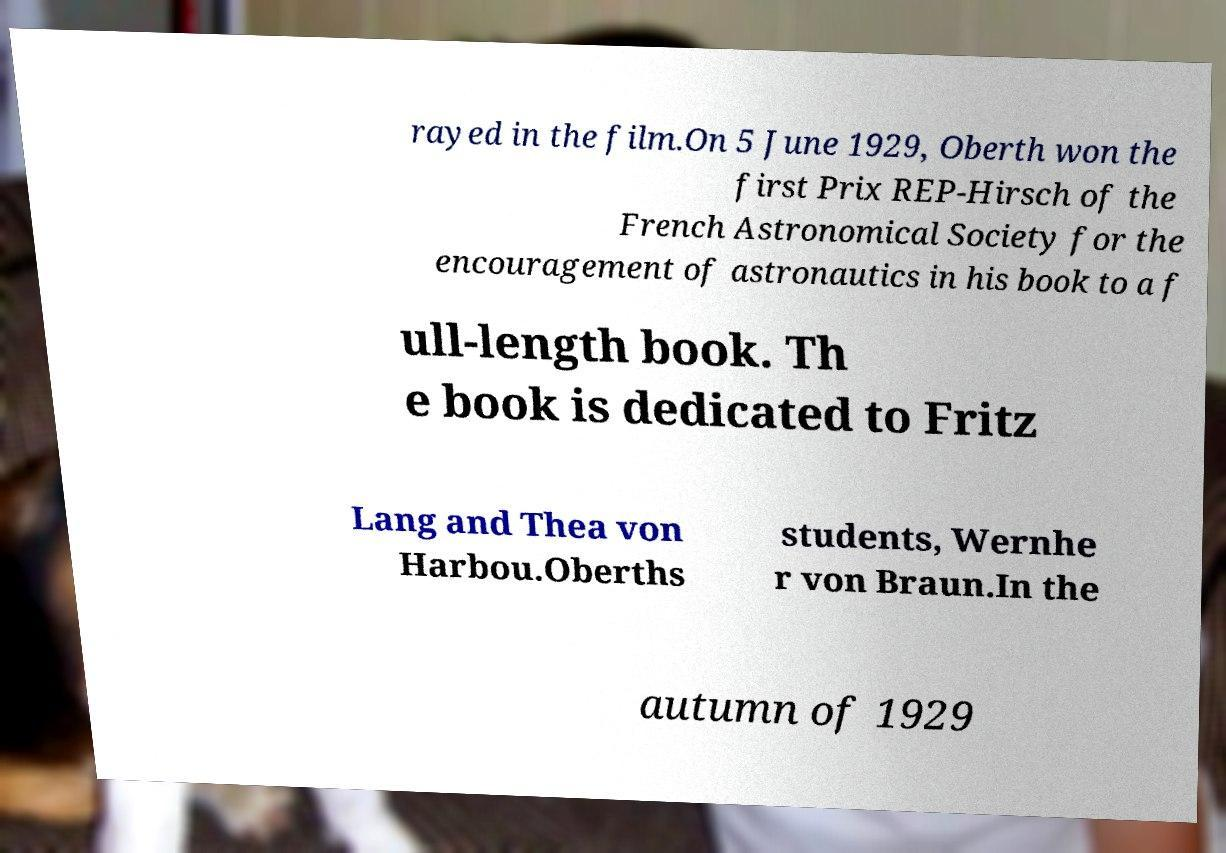Could you assist in decoding the text presented in this image and type it out clearly? rayed in the film.On 5 June 1929, Oberth won the first Prix REP-Hirsch of the French Astronomical Society for the encouragement of astronautics in his book to a f ull-length book. Th e book is dedicated to Fritz Lang and Thea von Harbou.Oberths students, Wernhe r von Braun.In the autumn of 1929 